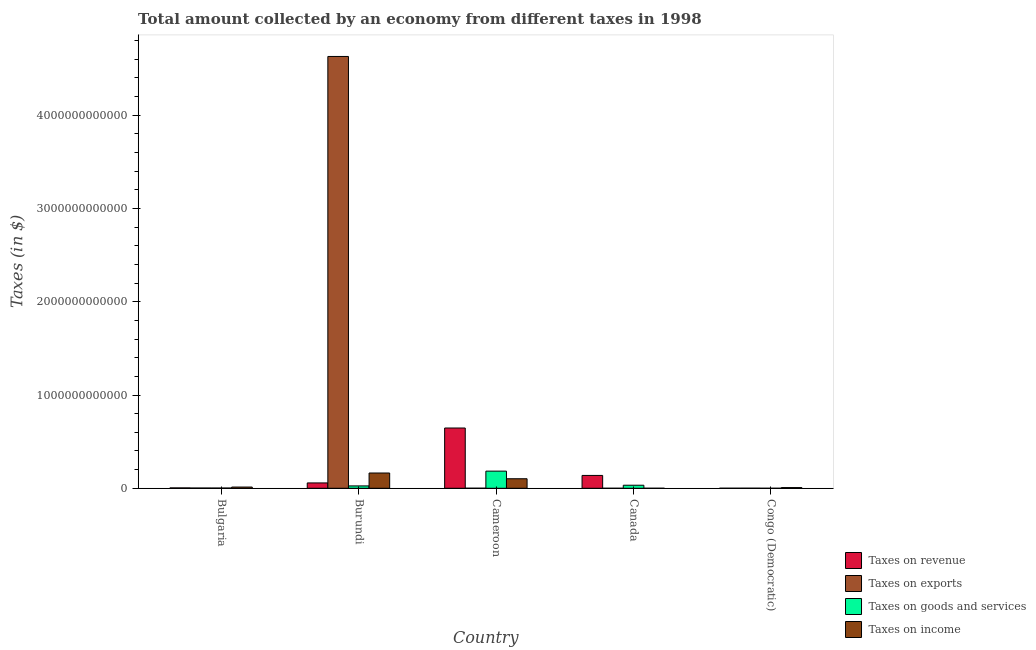How many groups of bars are there?
Your response must be concise. 5. Are the number of bars per tick equal to the number of legend labels?
Your answer should be very brief. Yes. How many bars are there on the 2nd tick from the left?
Your response must be concise. 4. What is the label of the 5th group of bars from the left?
Offer a terse response. Congo (Democratic). In how many cases, is the number of bars for a given country not equal to the number of legend labels?
Give a very brief answer. 0. What is the amount collected as tax on revenue in Bulgaria?
Your answer should be compact. 4.16e+09. Across all countries, what is the maximum amount collected as tax on revenue?
Offer a very short reply. 6.46e+11. Across all countries, what is the minimum amount collected as tax on goods?
Your answer should be compact. 1.04e+08. In which country was the amount collected as tax on exports maximum?
Your answer should be compact. Burundi. In which country was the amount collected as tax on goods minimum?
Provide a succinct answer. Congo (Democratic). What is the total amount collected as tax on goods in the graph?
Provide a short and direct response. 2.45e+11. What is the difference between the amount collected as tax on income in Bulgaria and that in Cameroon?
Offer a very short reply. -8.92e+1. What is the difference between the amount collected as tax on goods in Canada and the amount collected as tax on income in Cameroon?
Your answer should be very brief. -6.95e+1. What is the average amount collected as tax on income per country?
Make the answer very short. 5.73e+1. What is the difference between the amount collected as tax on revenue and amount collected as tax on exports in Burundi?
Offer a very short reply. -4.57e+12. In how many countries, is the amount collected as tax on exports greater than 4200000000000 $?
Offer a very short reply. 1. What is the ratio of the amount collected as tax on revenue in Bulgaria to that in Congo (Democratic)?
Provide a succinct answer. 7.79. Is the amount collected as tax on revenue in Canada less than that in Congo (Democratic)?
Give a very brief answer. No. What is the difference between the highest and the second highest amount collected as tax on income?
Your response must be concise. 6.14e+1. What is the difference between the highest and the lowest amount collected as tax on revenue?
Your response must be concise. 6.46e+11. Is the sum of the amount collected as tax on goods in Burundi and Congo (Democratic) greater than the maximum amount collected as tax on income across all countries?
Your answer should be compact. No. Is it the case that in every country, the sum of the amount collected as tax on exports and amount collected as tax on goods is greater than the sum of amount collected as tax on income and amount collected as tax on revenue?
Offer a very short reply. No. What does the 2nd bar from the left in Cameroon represents?
Offer a very short reply. Taxes on exports. What does the 2nd bar from the right in Bulgaria represents?
Your answer should be compact. Taxes on goods and services. Is it the case that in every country, the sum of the amount collected as tax on revenue and amount collected as tax on exports is greater than the amount collected as tax on goods?
Ensure brevity in your answer.  Yes. How many bars are there?
Make the answer very short. 20. Are all the bars in the graph horizontal?
Provide a succinct answer. No. How many countries are there in the graph?
Offer a very short reply. 5. What is the difference between two consecutive major ticks on the Y-axis?
Offer a very short reply. 1.00e+12. Does the graph contain any zero values?
Give a very brief answer. No. Where does the legend appear in the graph?
Offer a very short reply. Bottom right. What is the title of the graph?
Your answer should be very brief. Total amount collected by an economy from different taxes in 1998. What is the label or title of the X-axis?
Offer a terse response. Country. What is the label or title of the Y-axis?
Your answer should be very brief. Taxes (in $). What is the Taxes (in $) of Taxes on revenue in Bulgaria?
Ensure brevity in your answer.  4.16e+09. What is the Taxes (in $) of Taxes on exports in Bulgaria?
Keep it short and to the point. 2.76e+09. What is the Taxes (in $) of Taxes on goods and services in Bulgaria?
Make the answer very short. 2.53e+09. What is the Taxes (in $) of Taxes on income in Bulgaria?
Your response must be concise. 1.31e+1. What is the Taxes (in $) in Taxes on revenue in Burundi?
Ensure brevity in your answer.  5.74e+1. What is the Taxes (in $) in Taxes on exports in Burundi?
Your answer should be very brief. 4.63e+12. What is the Taxes (in $) in Taxes on goods and services in Burundi?
Keep it short and to the point. 2.53e+1. What is the Taxes (in $) in Taxes on income in Burundi?
Provide a succinct answer. 1.64e+11. What is the Taxes (in $) of Taxes on revenue in Cameroon?
Offer a very short reply. 6.46e+11. What is the Taxes (in $) in Taxes on exports in Cameroon?
Offer a very short reply. 6.23e+08. What is the Taxes (in $) of Taxes on goods and services in Cameroon?
Your answer should be compact. 1.84e+11. What is the Taxes (in $) in Taxes on income in Cameroon?
Your answer should be very brief. 1.02e+11. What is the Taxes (in $) in Taxes on revenue in Canada?
Give a very brief answer. 1.38e+11. What is the Taxes (in $) in Taxes on goods and services in Canada?
Ensure brevity in your answer.  3.28e+1. What is the Taxes (in $) in Taxes on income in Canada?
Keep it short and to the point. 1.77e+08. What is the Taxes (in $) in Taxes on revenue in Congo (Democratic)?
Offer a terse response. 5.34e+08. What is the Taxes (in $) in Taxes on exports in Congo (Democratic)?
Offer a very short reply. 7.60e+08. What is the Taxes (in $) in Taxes on goods and services in Congo (Democratic)?
Make the answer very short. 1.04e+08. What is the Taxes (in $) of Taxes on income in Congo (Democratic)?
Keep it short and to the point. 7.38e+09. Across all countries, what is the maximum Taxes (in $) in Taxes on revenue?
Offer a very short reply. 6.46e+11. Across all countries, what is the maximum Taxes (in $) of Taxes on exports?
Your response must be concise. 4.63e+12. Across all countries, what is the maximum Taxes (in $) in Taxes on goods and services?
Your answer should be very brief. 1.84e+11. Across all countries, what is the maximum Taxes (in $) in Taxes on income?
Provide a short and direct response. 1.64e+11. Across all countries, what is the minimum Taxes (in $) of Taxes on revenue?
Give a very brief answer. 5.34e+08. Across all countries, what is the minimum Taxes (in $) of Taxes on exports?
Your response must be concise. 1.00e+06. Across all countries, what is the minimum Taxes (in $) in Taxes on goods and services?
Ensure brevity in your answer.  1.04e+08. Across all countries, what is the minimum Taxes (in $) of Taxes on income?
Your response must be concise. 1.77e+08. What is the total Taxes (in $) of Taxes on revenue in the graph?
Your answer should be compact. 8.46e+11. What is the total Taxes (in $) of Taxes on exports in the graph?
Provide a short and direct response. 4.63e+12. What is the total Taxes (in $) of Taxes on goods and services in the graph?
Your answer should be very brief. 2.45e+11. What is the total Taxes (in $) of Taxes on income in the graph?
Offer a terse response. 2.87e+11. What is the difference between the Taxes (in $) in Taxes on revenue in Bulgaria and that in Burundi?
Offer a very short reply. -5.33e+1. What is the difference between the Taxes (in $) of Taxes on exports in Bulgaria and that in Burundi?
Your answer should be compact. -4.63e+12. What is the difference between the Taxes (in $) in Taxes on goods and services in Bulgaria and that in Burundi?
Your response must be concise. -2.28e+1. What is the difference between the Taxes (in $) in Taxes on income in Bulgaria and that in Burundi?
Your response must be concise. -1.51e+11. What is the difference between the Taxes (in $) of Taxes on revenue in Bulgaria and that in Cameroon?
Provide a short and direct response. -6.42e+11. What is the difference between the Taxes (in $) of Taxes on exports in Bulgaria and that in Cameroon?
Offer a terse response. 2.14e+09. What is the difference between the Taxes (in $) in Taxes on goods and services in Bulgaria and that in Cameroon?
Give a very brief answer. -1.81e+11. What is the difference between the Taxes (in $) of Taxes on income in Bulgaria and that in Cameroon?
Give a very brief answer. -8.92e+1. What is the difference between the Taxes (in $) in Taxes on revenue in Bulgaria and that in Canada?
Make the answer very short. -1.34e+11. What is the difference between the Taxes (in $) of Taxes on exports in Bulgaria and that in Canada?
Ensure brevity in your answer.  2.76e+09. What is the difference between the Taxes (in $) of Taxes on goods and services in Bulgaria and that in Canada?
Keep it short and to the point. -3.02e+1. What is the difference between the Taxes (in $) of Taxes on income in Bulgaria and that in Canada?
Offer a very short reply. 1.30e+1. What is the difference between the Taxes (in $) of Taxes on revenue in Bulgaria and that in Congo (Democratic)?
Your response must be concise. 3.63e+09. What is the difference between the Taxes (in $) in Taxes on exports in Bulgaria and that in Congo (Democratic)?
Give a very brief answer. 2.00e+09. What is the difference between the Taxes (in $) of Taxes on goods and services in Bulgaria and that in Congo (Democratic)?
Provide a succinct answer. 2.42e+09. What is the difference between the Taxes (in $) of Taxes on income in Bulgaria and that in Congo (Democratic)?
Give a very brief answer. 5.76e+09. What is the difference between the Taxes (in $) in Taxes on revenue in Burundi and that in Cameroon?
Offer a terse response. -5.89e+11. What is the difference between the Taxes (in $) of Taxes on exports in Burundi and that in Cameroon?
Your response must be concise. 4.63e+12. What is the difference between the Taxes (in $) in Taxes on goods and services in Burundi and that in Cameroon?
Offer a very short reply. -1.59e+11. What is the difference between the Taxes (in $) in Taxes on income in Burundi and that in Cameroon?
Keep it short and to the point. 6.14e+1. What is the difference between the Taxes (in $) of Taxes on revenue in Burundi and that in Canada?
Your response must be concise. -8.03e+1. What is the difference between the Taxes (in $) in Taxes on exports in Burundi and that in Canada?
Offer a terse response. 4.63e+12. What is the difference between the Taxes (in $) of Taxes on goods and services in Burundi and that in Canada?
Make the answer very short. -7.47e+09. What is the difference between the Taxes (in $) of Taxes on income in Burundi and that in Canada?
Offer a terse response. 1.64e+11. What is the difference between the Taxes (in $) in Taxes on revenue in Burundi and that in Congo (Democratic)?
Offer a very short reply. 5.69e+1. What is the difference between the Taxes (in $) in Taxes on exports in Burundi and that in Congo (Democratic)?
Make the answer very short. 4.63e+12. What is the difference between the Taxes (in $) of Taxes on goods and services in Burundi and that in Congo (Democratic)?
Keep it short and to the point. 2.52e+1. What is the difference between the Taxes (in $) of Taxes on income in Burundi and that in Congo (Democratic)?
Offer a terse response. 1.56e+11. What is the difference between the Taxes (in $) in Taxes on revenue in Cameroon and that in Canada?
Offer a very short reply. 5.08e+11. What is the difference between the Taxes (in $) of Taxes on exports in Cameroon and that in Canada?
Offer a terse response. 6.22e+08. What is the difference between the Taxes (in $) of Taxes on goods and services in Cameroon and that in Canada?
Your answer should be compact. 1.51e+11. What is the difference between the Taxes (in $) of Taxes on income in Cameroon and that in Canada?
Provide a succinct answer. 1.02e+11. What is the difference between the Taxes (in $) in Taxes on revenue in Cameroon and that in Congo (Democratic)?
Offer a terse response. 6.46e+11. What is the difference between the Taxes (in $) of Taxes on exports in Cameroon and that in Congo (Democratic)?
Ensure brevity in your answer.  -1.37e+08. What is the difference between the Taxes (in $) in Taxes on goods and services in Cameroon and that in Congo (Democratic)?
Your answer should be compact. 1.84e+11. What is the difference between the Taxes (in $) of Taxes on income in Cameroon and that in Congo (Democratic)?
Offer a terse response. 9.49e+1. What is the difference between the Taxes (in $) of Taxes on revenue in Canada and that in Congo (Democratic)?
Give a very brief answer. 1.37e+11. What is the difference between the Taxes (in $) in Taxes on exports in Canada and that in Congo (Democratic)?
Ensure brevity in your answer.  -7.59e+08. What is the difference between the Taxes (in $) in Taxes on goods and services in Canada and that in Congo (Democratic)?
Your answer should be very brief. 3.27e+1. What is the difference between the Taxes (in $) in Taxes on income in Canada and that in Congo (Democratic)?
Your answer should be very brief. -7.20e+09. What is the difference between the Taxes (in $) in Taxes on revenue in Bulgaria and the Taxes (in $) in Taxes on exports in Burundi?
Provide a succinct answer. -4.63e+12. What is the difference between the Taxes (in $) of Taxes on revenue in Bulgaria and the Taxes (in $) of Taxes on goods and services in Burundi?
Your response must be concise. -2.11e+1. What is the difference between the Taxes (in $) of Taxes on revenue in Bulgaria and the Taxes (in $) of Taxes on income in Burundi?
Keep it short and to the point. -1.60e+11. What is the difference between the Taxes (in $) of Taxes on exports in Bulgaria and the Taxes (in $) of Taxes on goods and services in Burundi?
Ensure brevity in your answer.  -2.25e+1. What is the difference between the Taxes (in $) in Taxes on exports in Bulgaria and the Taxes (in $) in Taxes on income in Burundi?
Your answer should be very brief. -1.61e+11. What is the difference between the Taxes (in $) in Taxes on goods and services in Bulgaria and the Taxes (in $) in Taxes on income in Burundi?
Your answer should be compact. -1.61e+11. What is the difference between the Taxes (in $) of Taxes on revenue in Bulgaria and the Taxes (in $) of Taxes on exports in Cameroon?
Your response must be concise. 3.54e+09. What is the difference between the Taxes (in $) of Taxes on revenue in Bulgaria and the Taxes (in $) of Taxes on goods and services in Cameroon?
Offer a terse response. -1.80e+11. What is the difference between the Taxes (in $) in Taxes on revenue in Bulgaria and the Taxes (in $) in Taxes on income in Cameroon?
Ensure brevity in your answer.  -9.81e+1. What is the difference between the Taxes (in $) in Taxes on exports in Bulgaria and the Taxes (in $) in Taxes on goods and services in Cameroon?
Give a very brief answer. -1.81e+11. What is the difference between the Taxes (in $) in Taxes on exports in Bulgaria and the Taxes (in $) in Taxes on income in Cameroon?
Provide a succinct answer. -9.95e+1. What is the difference between the Taxes (in $) of Taxes on goods and services in Bulgaria and the Taxes (in $) of Taxes on income in Cameroon?
Your response must be concise. -9.98e+1. What is the difference between the Taxes (in $) in Taxes on revenue in Bulgaria and the Taxes (in $) in Taxes on exports in Canada?
Keep it short and to the point. 4.16e+09. What is the difference between the Taxes (in $) in Taxes on revenue in Bulgaria and the Taxes (in $) in Taxes on goods and services in Canada?
Offer a terse response. -2.86e+1. What is the difference between the Taxes (in $) in Taxes on revenue in Bulgaria and the Taxes (in $) in Taxes on income in Canada?
Offer a terse response. 3.99e+09. What is the difference between the Taxes (in $) of Taxes on exports in Bulgaria and the Taxes (in $) of Taxes on goods and services in Canada?
Your answer should be compact. -3.00e+1. What is the difference between the Taxes (in $) in Taxes on exports in Bulgaria and the Taxes (in $) in Taxes on income in Canada?
Provide a succinct answer. 2.58e+09. What is the difference between the Taxes (in $) of Taxes on goods and services in Bulgaria and the Taxes (in $) of Taxes on income in Canada?
Provide a short and direct response. 2.35e+09. What is the difference between the Taxes (in $) in Taxes on revenue in Bulgaria and the Taxes (in $) in Taxes on exports in Congo (Democratic)?
Provide a short and direct response. 3.40e+09. What is the difference between the Taxes (in $) of Taxes on revenue in Bulgaria and the Taxes (in $) of Taxes on goods and services in Congo (Democratic)?
Ensure brevity in your answer.  4.06e+09. What is the difference between the Taxes (in $) of Taxes on revenue in Bulgaria and the Taxes (in $) of Taxes on income in Congo (Democratic)?
Your answer should be compact. -3.21e+09. What is the difference between the Taxes (in $) of Taxes on exports in Bulgaria and the Taxes (in $) of Taxes on goods and services in Congo (Democratic)?
Give a very brief answer. 2.66e+09. What is the difference between the Taxes (in $) of Taxes on exports in Bulgaria and the Taxes (in $) of Taxes on income in Congo (Democratic)?
Give a very brief answer. -4.62e+09. What is the difference between the Taxes (in $) of Taxes on goods and services in Bulgaria and the Taxes (in $) of Taxes on income in Congo (Democratic)?
Make the answer very short. -4.85e+09. What is the difference between the Taxes (in $) of Taxes on revenue in Burundi and the Taxes (in $) of Taxes on exports in Cameroon?
Provide a succinct answer. 5.68e+1. What is the difference between the Taxes (in $) of Taxes on revenue in Burundi and the Taxes (in $) of Taxes on goods and services in Cameroon?
Provide a short and direct response. -1.26e+11. What is the difference between the Taxes (in $) in Taxes on revenue in Burundi and the Taxes (in $) in Taxes on income in Cameroon?
Provide a succinct answer. -4.49e+1. What is the difference between the Taxes (in $) in Taxes on exports in Burundi and the Taxes (in $) in Taxes on goods and services in Cameroon?
Your answer should be compact. 4.45e+12. What is the difference between the Taxes (in $) in Taxes on exports in Burundi and the Taxes (in $) in Taxes on income in Cameroon?
Your response must be concise. 4.53e+12. What is the difference between the Taxes (in $) in Taxes on goods and services in Burundi and the Taxes (in $) in Taxes on income in Cameroon?
Your answer should be very brief. -7.70e+1. What is the difference between the Taxes (in $) in Taxes on revenue in Burundi and the Taxes (in $) in Taxes on exports in Canada?
Provide a short and direct response. 5.74e+1. What is the difference between the Taxes (in $) of Taxes on revenue in Burundi and the Taxes (in $) of Taxes on goods and services in Canada?
Provide a short and direct response. 2.46e+1. What is the difference between the Taxes (in $) of Taxes on revenue in Burundi and the Taxes (in $) of Taxes on income in Canada?
Keep it short and to the point. 5.72e+1. What is the difference between the Taxes (in $) of Taxes on exports in Burundi and the Taxes (in $) of Taxes on goods and services in Canada?
Offer a very short reply. 4.60e+12. What is the difference between the Taxes (in $) of Taxes on exports in Burundi and the Taxes (in $) of Taxes on income in Canada?
Offer a very short reply. 4.63e+12. What is the difference between the Taxes (in $) of Taxes on goods and services in Burundi and the Taxes (in $) of Taxes on income in Canada?
Your answer should be very brief. 2.51e+1. What is the difference between the Taxes (in $) of Taxes on revenue in Burundi and the Taxes (in $) of Taxes on exports in Congo (Democratic)?
Provide a succinct answer. 5.67e+1. What is the difference between the Taxes (in $) of Taxes on revenue in Burundi and the Taxes (in $) of Taxes on goods and services in Congo (Democratic)?
Offer a terse response. 5.73e+1. What is the difference between the Taxes (in $) in Taxes on revenue in Burundi and the Taxes (in $) in Taxes on income in Congo (Democratic)?
Give a very brief answer. 5.00e+1. What is the difference between the Taxes (in $) in Taxes on exports in Burundi and the Taxes (in $) in Taxes on goods and services in Congo (Democratic)?
Your response must be concise. 4.63e+12. What is the difference between the Taxes (in $) of Taxes on exports in Burundi and the Taxes (in $) of Taxes on income in Congo (Democratic)?
Ensure brevity in your answer.  4.62e+12. What is the difference between the Taxes (in $) in Taxes on goods and services in Burundi and the Taxes (in $) in Taxes on income in Congo (Democratic)?
Offer a terse response. 1.79e+1. What is the difference between the Taxes (in $) of Taxes on revenue in Cameroon and the Taxes (in $) of Taxes on exports in Canada?
Ensure brevity in your answer.  6.46e+11. What is the difference between the Taxes (in $) in Taxes on revenue in Cameroon and the Taxes (in $) in Taxes on goods and services in Canada?
Your response must be concise. 6.13e+11. What is the difference between the Taxes (in $) of Taxes on revenue in Cameroon and the Taxes (in $) of Taxes on income in Canada?
Offer a terse response. 6.46e+11. What is the difference between the Taxes (in $) in Taxes on exports in Cameroon and the Taxes (in $) in Taxes on goods and services in Canada?
Ensure brevity in your answer.  -3.22e+1. What is the difference between the Taxes (in $) of Taxes on exports in Cameroon and the Taxes (in $) of Taxes on income in Canada?
Your answer should be very brief. 4.46e+08. What is the difference between the Taxes (in $) of Taxes on goods and services in Cameroon and the Taxes (in $) of Taxes on income in Canada?
Provide a short and direct response. 1.84e+11. What is the difference between the Taxes (in $) in Taxes on revenue in Cameroon and the Taxes (in $) in Taxes on exports in Congo (Democratic)?
Offer a very short reply. 6.45e+11. What is the difference between the Taxes (in $) of Taxes on revenue in Cameroon and the Taxes (in $) of Taxes on goods and services in Congo (Democratic)?
Your response must be concise. 6.46e+11. What is the difference between the Taxes (in $) of Taxes on revenue in Cameroon and the Taxes (in $) of Taxes on income in Congo (Democratic)?
Provide a succinct answer. 6.39e+11. What is the difference between the Taxes (in $) in Taxes on exports in Cameroon and the Taxes (in $) in Taxes on goods and services in Congo (Democratic)?
Ensure brevity in your answer.  5.19e+08. What is the difference between the Taxes (in $) in Taxes on exports in Cameroon and the Taxes (in $) in Taxes on income in Congo (Democratic)?
Your answer should be very brief. -6.75e+09. What is the difference between the Taxes (in $) in Taxes on goods and services in Cameroon and the Taxes (in $) in Taxes on income in Congo (Democratic)?
Give a very brief answer. 1.76e+11. What is the difference between the Taxes (in $) of Taxes on revenue in Canada and the Taxes (in $) of Taxes on exports in Congo (Democratic)?
Your answer should be very brief. 1.37e+11. What is the difference between the Taxes (in $) in Taxes on revenue in Canada and the Taxes (in $) in Taxes on goods and services in Congo (Democratic)?
Offer a terse response. 1.38e+11. What is the difference between the Taxes (in $) of Taxes on revenue in Canada and the Taxes (in $) of Taxes on income in Congo (Democratic)?
Give a very brief answer. 1.30e+11. What is the difference between the Taxes (in $) in Taxes on exports in Canada and the Taxes (in $) in Taxes on goods and services in Congo (Democratic)?
Give a very brief answer. -1.03e+08. What is the difference between the Taxes (in $) in Taxes on exports in Canada and the Taxes (in $) in Taxes on income in Congo (Democratic)?
Ensure brevity in your answer.  -7.38e+09. What is the difference between the Taxes (in $) in Taxes on goods and services in Canada and the Taxes (in $) in Taxes on income in Congo (Democratic)?
Your response must be concise. 2.54e+1. What is the average Taxes (in $) in Taxes on revenue per country?
Provide a short and direct response. 1.69e+11. What is the average Taxes (in $) in Taxes on exports per country?
Your answer should be very brief. 9.27e+11. What is the average Taxes (in $) in Taxes on goods and services per country?
Your response must be concise. 4.89e+1. What is the average Taxes (in $) of Taxes on income per country?
Provide a short and direct response. 5.73e+1. What is the difference between the Taxes (in $) in Taxes on revenue and Taxes (in $) in Taxes on exports in Bulgaria?
Ensure brevity in your answer.  1.40e+09. What is the difference between the Taxes (in $) in Taxes on revenue and Taxes (in $) in Taxes on goods and services in Bulgaria?
Offer a very short reply. 1.64e+09. What is the difference between the Taxes (in $) of Taxes on revenue and Taxes (in $) of Taxes on income in Bulgaria?
Offer a very short reply. -8.97e+09. What is the difference between the Taxes (in $) in Taxes on exports and Taxes (in $) in Taxes on goods and services in Bulgaria?
Your response must be concise. 2.34e+08. What is the difference between the Taxes (in $) in Taxes on exports and Taxes (in $) in Taxes on income in Bulgaria?
Your response must be concise. -1.04e+1. What is the difference between the Taxes (in $) in Taxes on goods and services and Taxes (in $) in Taxes on income in Bulgaria?
Your response must be concise. -1.06e+1. What is the difference between the Taxes (in $) of Taxes on revenue and Taxes (in $) of Taxes on exports in Burundi?
Make the answer very short. -4.57e+12. What is the difference between the Taxes (in $) of Taxes on revenue and Taxes (in $) of Taxes on goods and services in Burundi?
Make the answer very short. 3.21e+1. What is the difference between the Taxes (in $) in Taxes on revenue and Taxes (in $) in Taxes on income in Burundi?
Your response must be concise. -1.06e+11. What is the difference between the Taxes (in $) of Taxes on exports and Taxes (in $) of Taxes on goods and services in Burundi?
Your answer should be compact. 4.60e+12. What is the difference between the Taxes (in $) of Taxes on exports and Taxes (in $) of Taxes on income in Burundi?
Provide a succinct answer. 4.47e+12. What is the difference between the Taxes (in $) in Taxes on goods and services and Taxes (in $) in Taxes on income in Burundi?
Offer a terse response. -1.38e+11. What is the difference between the Taxes (in $) of Taxes on revenue and Taxes (in $) of Taxes on exports in Cameroon?
Give a very brief answer. 6.46e+11. What is the difference between the Taxes (in $) of Taxes on revenue and Taxes (in $) of Taxes on goods and services in Cameroon?
Your response must be concise. 4.62e+11. What is the difference between the Taxes (in $) of Taxes on revenue and Taxes (in $) of Taxes on income in Cameroon?
Your answer should be compact. 5.44e+11. What is the difference between the Taxes (in $) in Taxes on exports and Taxes (in $) in Taxes on goods and services in Cameroon?
Your response must be concise. -1.83e+11. What is the difference between the Taxes (in $) in Taxes on exports and Taxes (in $) in Taxes on income in Cameroon?
Keep it short and to the point. -1.02e+11. What is the difference between the Taxes (in $) of Taxes on goods and services and Taxes (in $) of Taxes on income in Cameroon?
Offer a terse response. 8.15e+1. What is the difference between the Taxes (in $) of Taxes on revenue and Taxes (in $) of Taxes on exports in Canada?
Give a very brief answer. 1.38e+11. What is the difference between the Taxes (in $) in Taxes on revenue and Taxes (in $) in Taxes on goods and services in Canada?
Your answer should be compact. 1.05e+11. What is the difference between the Taxes (in $) of Taxes on revenue and Taxes (in $) of Taxes on income in Canada?
Provide a short and direct response. 1.38e+11. What is the difference between the Taxes (in $) in Taxes on exports and Taxes (in $) in Taxes on goods and services in Canada?
Provide a short and direct response. -3.28e+1. What is the difference between the Taxes (in $) of Taxes on exports and Taxes (in $) of Taxes on income in Canada?
Your answer should be very brief. -1.76e+08. What is the difference between the Taxes (in $) in Taxes on goods and services and Taxes (in $) in Taxes on income in Canada?
Keep it short and to the point. 3.26e+1. What is the difference between the Taxes (in $) of Taxes on revenue and Taxes (in $) of Taxes on exports in Congo (Democratic)?
Your answer should be compact. -2.26e+08. What is the difference between the Taxes (in $) in Taxes on revenue and Taxes (in $) in Taxes on goods and services in Congo (Democratic)?
Offer a very short reply. 4.30e+08. What is the difference between the Taxes (in $) of Taxes on revenue and Taxes (in $) of Taxes on income in Congo (Democratic)?
Provide a short and direct response. -6.84e+09. What is the difference between the Taxes (in $) in Taxes on exports and Taxes (in $) in Taxes on goods and services in Congo (Democratic)?
Make the answer very short. 6.56e+08. What is the difference between the Taxes (in $) of Taxes on exports and Taxes (in $) of Taxes on income in Congo (Democratic)?
Make the answer very short. -6.62e+09. What is the difference between the Taxes (in $) in Taxes on goods and services and Taxes (in $) in Taxes on income in Congo (Democratic)?
Keep it short and to the point. -7.27e+09. What is the ratio of the Taxes (in $) of Taxes on revenue in Bulgaria to that in Burundi?
Offer a terse response. 0.07. What is the ratio of the Taxes (in $) in Taxes on exports in Bulgaria to that in Burundi?
Give a very brief answer. 0. What is the ratio of the Taxes (in $) of Taxes on goods and services in Bulgaria to that in Burundi?
Make the answer very short. 0.1. What is the ratio of the Taxes (in $) of Taxes on income in Bulgaria to that in Burundi?
Ensure brevity in your answer.  0.08. What is the ratio of the Taxes (in $) in Taxes on revenue in Bulgaria to that in Cameroon?
Your answer should be very brief. 0.01. What is the ratio of the Taxes (in $) in Taxes on exports in Bulgaria to that in Cameroon?
Give a very brief answer. 4.43. What is the ratio of the Taxes (in $) of Taxes on goods and services in Bulgaria to that in Cameroon?
Provide a short and direct response. 0.01. What is the ratio of the Taxes (in $) in Taxes on income in Bulgaria to that in Cameroon?
Keep it short and to the point. 0.13. What is the ratio of the Taxes (in $) in Taxes on revenue in Bulgaria to that in Canada?
Your answer should be compact. 0.03. What is the ratio of the Taxes (in $) of Taxes on exports in Bulgaria to that in Canada?
Keep it short and to the point. 2760. What is the ratio of the Taxes (in $) in Taxes on goods and services in Bulgaria to that in Canada?
Keep it short and to the point. 0.08. What is the ratio of the Taxes (in $) of Taxes on income in Bulgaria to that in Canada?
Give a very brief answer. 74.35. What is the ratio of the Taxes (in $) in Taxes on revenue in Bulgaria to that in Congo (Democratic)?
Offer a terse response. 7.79. What is the ratio of the Taxes (in $) in Taxes on exports in Bulgaria to that in Congo (Democratic)?
Your answer should be compact. 3.63. What is the ratio of the Taxes (in $) in Taxes on goods and services in Bulgaria to that in Congo (Democratic)?
Keep it short and to the point. 24.24. What is the ratio of the Taxes (in $) in Taxes on income in Bulgaria to that in Congo (Democratic)?
Your answer should be compact. 1.78. What is the ratio of the Taxes (in $) in Taxes on revenue in Burundi to that in Cameroon?
Give a very brief answer. 0.09. What is the ratio of the Taxes (in $) of Taxes on exports in Burundi to that in Cameroon?
Give a very brief answer. 7431.78. What is the ratio of the Taxes (in $) of Taxes on goods and services in Burundi to that in Cameroon?
Provide a succinct answer. 0.14. What is the ratio of the Taxes (in $) in Taxes on income in Burundi to that in Cameroon?
Provide a short and direct response. 1.6. What is the ratio of the Taxes (in $) of Taxes on revenue in Burundi to that in Canada?
Ensure brevity in your answer.  0.42. What is the ratio of the Taxes (in $) of Taxes on exports in Burundi to that in Canada?
Your answer should be very brief. 4.63e+06. What is the ratio of the Taxes (in $) in Taxes on goods and services in Burundi to that in Canada?
Provide a short and direct response. 0.77. What is the ratio of the Taxes (in $) of Taxes on income in Burundi to that in Canada?
Provide a succinct answer. 926.28. What is the ratio of the Taxes (in $) in Taxes on revenue in Burundi to that in Congo (Democratic)?
Keep it short and to the point. 107.44. What is the ratio of the Taxes (in $) of Taxes on exports in Burundi to that in Congo (Democratic)?
Provide a short and direct response. 6092.11. What is the ratio of the Taxes (in $) of Taxes on goods and services in Burundi to that in Congo (Democratic)?
Your answer should be very brief. 242.8. What is the ratio of the Taxes (in $) of Taxes on income in Burundi to that in Congo (Democratic)?
Keep it short and to the point. 22.19. What is the ratio of the Taxes (in $) of Taxes on revenue in Cameroon to that in Canada?
Make the answer very short. 4.69. What is the ratio of the Taxes (in $) in Taxes on exports in Cameroon to that in Canada?
Ensure brevity in your answer.  623. What is the ratio of the Taxes (in $) in Taxes on goods and services in Cameroon to that in Canada?
Provide a succinct answer. 5.61. What is the ratio of the Taxes (in $) in Taxes on income in Cameroon to that in Canada?
Your response must be concise. 578.89. What is the ratio of the Taxes (in $) of Taxes on revenue in Cameroon to that in Congo (Democratic)?
Provide a short and direct response. 1209.09. What is the ratio of the Taxes (in $) in Taxes on exports in Cameroon to that in Congo (Democratic)?
Offer a very short reply. 0.82. What is the ratio of the Taxes (in $) in Taxes on goods and services in Cameroon to that in Congo (Democratic)?
Your response must be concise. 1763.77. What is the ratio of the Taxes (in $) in Taxes on income in Cameroon to that in Congo (Democratic)?
Your response must be concise. 13.87. What is the ratio of the Taxes (in $) in Taxes on revenue in Canada to that in Congo (Democratic)?
Your answer should be very brief. 257.76. What is the ratio of the Taxes (in $) of Taxes on exports in Canada to that in Congo (Democratic)?
Offer a very short reply. 0. What is the ratio of the Taxes (in $) of Taxes on goods and services in Canada to that in Congo (Democratic)?
Keep it short and to the point. 314.49. What is the ratio of the Taxes (in $) in Taxes on income in Canada to that in Congo (Democratic)?
Ensure brevity in your answer.  0.02. What is the difference between the highest and the second highest Taxes (in $) in Taxes on revenue?
Your response must be concise. 5.08e+11. What is the difference between the highest and the second highest Taxes (in $) in Taxes on exports?
Keep it short and to the point. 4.63e+12. What is the difference between the highest and the second highest Taxes (in $) of Taxes on goods and services?
Provide a succinct answer. 1.51e+11. What is the difference between the highest and the second highest Taxes (in $) of Taxes on income?
Your response must be concise. 6.14e+1. What is the difference between the highest and the lowest Taxes (in $) in Taxes on revenue?
Provide a succinct answer. 6.46e+11. What is the difference between the highest and the lowest Taxes (in $) in Taxes on exports?
Your response must be concise. 4.63e+12. What is the difference between the highest and the lowest Taxes (in $) of Taxes on goods and services?
Offer a very short reply. 1.84e+11. What is the difference between the highest and the lowest Taxes (in $) in Taxes on income?
Provide a short and direct response. 1.64e+11. 